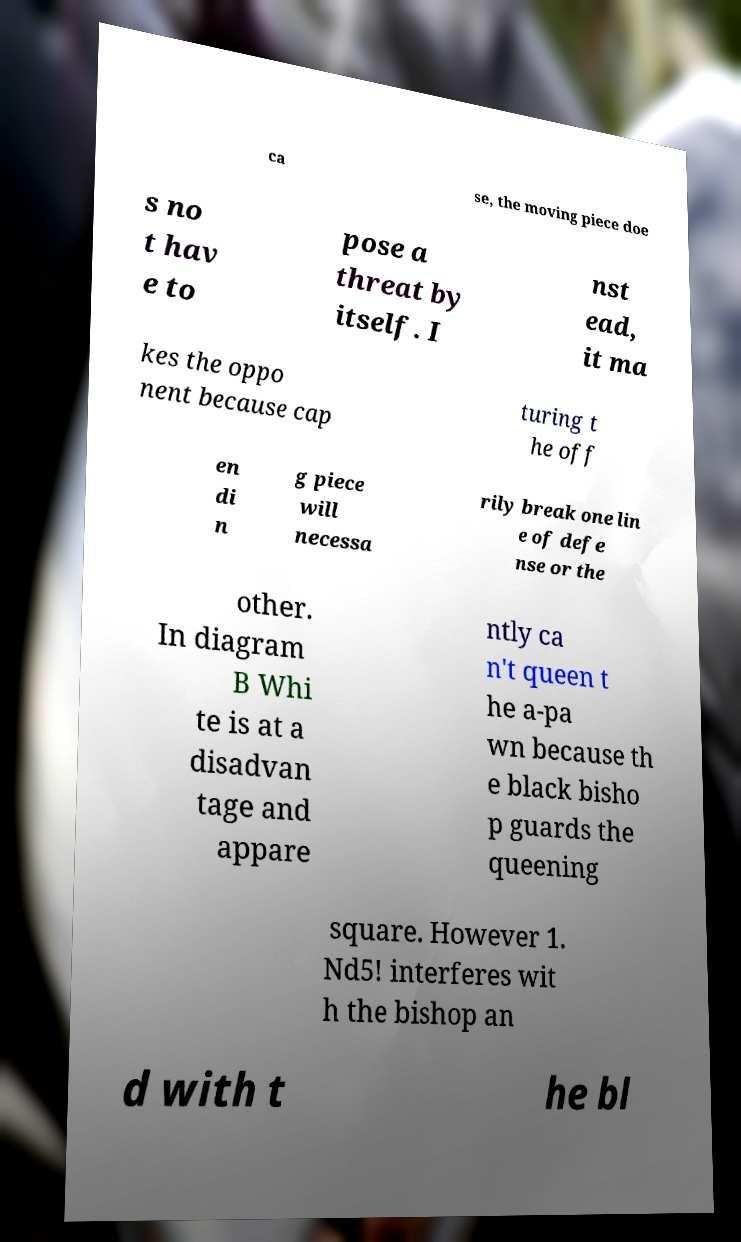Could you extract and type out the text from this image? ca se, the moving piece doe s no t hav e to pose a threat by itself. I nst ead, it ma kes the oppo nent because cap turing t he off en di n g piece will necessa rily break one lin e of defe nse or the other. In diagram B Whi te is at a disadvan tage and appare ntly ca n't queen t he a-pa wn because th e black bisho p guards the queening square. However 1. Nd5! interferes wit h the bishop an d with t he bl 